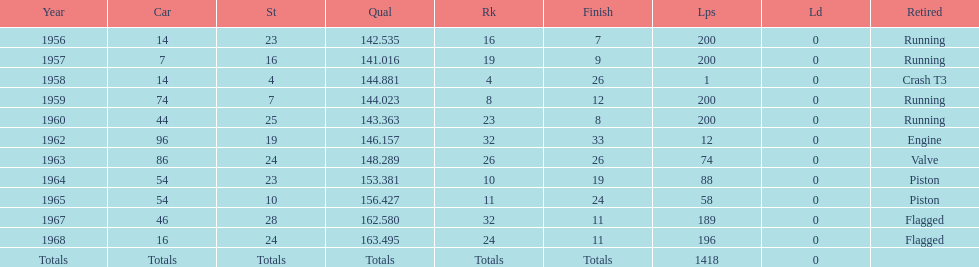What is the larger laps between 1963 or 1968 1968. 